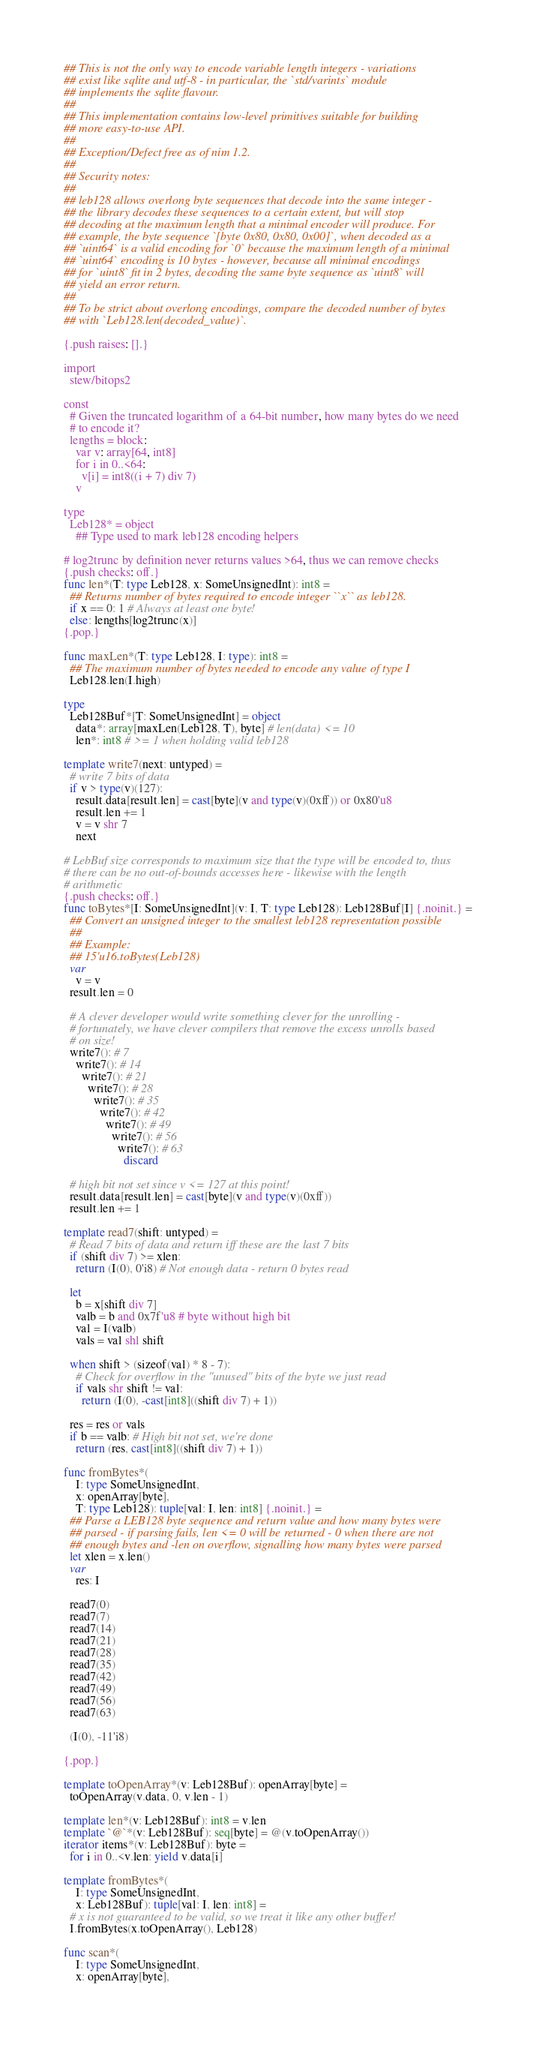Convert code to text. <code><loc_0><loc_0><loc_500><loc_500><_Nim_>## This is not the only way to encode variable length integers - variations
## exist like sqlite and utf-8 - in particular, the `std/varints` module
## implements the sqlite flavour.
##
## This implementation contains low-level primitives suitable for building
## more easy-to-use API.
##
## Exception/Defect free as of nim 1.2.
##
## Security notes:
##
## leb128 allows overlong byte sequences that decode into the same integer -
## the library decodes these sequences to a certain extent, but will stop
## decoding at the maximum length that a minimal encoder will produce. For
## example, the byte sequence `[byte 0x80, 0x80, 0x00]`, when decoded as a
## `uint64` is a valid encoding for `0` because the maximum length of a minimal
## `uint64` encoding is 10 bytes - however, because all minimal encodings
## for `uint8` fit in 2 bytes, decoding the same byte sequence as `uint8` will
## yield an error return.
##
## To be strict about overlong encodings, compare the decoded number of bytes
## with `Leb128.len(decoded_value)`.

{.push raises: [].}

import
  stew/bitops2

const
  # Given the truncated logarithm of a 64-bit number, how many bytes do we need
  # to encode it?
  lengths = block:
    var v: array[64, int8]
    for i in 0..<64:
      v[i] = int8((i + 7) div 7)
    v

type
  Leb128* = object
    ## Type used to mark leb128 encoding helpers

# log2trunc by definition never returns values >64, thus we can remove checks
{.push checks: off.}
func len*(T: type Leb128, x: SomeUnsignedInt): int8 =
  ## Returns number of bytes required to encode integer ``x`` as leb128.
  if x == 0: 1 # Always at least one byte!
  else: lengths[log2trunc(x)]
{.pop.}

func maxLen*(T: type Leb128, I: type): int8 =
  ## The maximum number of bytes needed to encode any value of type I
  Leb128.len(I.high)

type
  Leb128Buf*[T: SomeUnsignedInt] = object
    data*: array[maxLen(Leb128, T), byte] # len(data) <= 10
    len*: int8 # >= 1 when holding valid leb128

template write7(next: untyped) =
  # write 7 bits of data
  if v > type(v)(127):
    result.data[result.len] = cast[byte](v and type(v)(0xff)) or 0x80'u8
    result.len += 1
    v = v shr 7
    next

# LebBuf size corresponds to maximum size that the type will be encoded to, thus
# there can be no out-of-bounds accesses here - likewise with the length
# arithmetic
{.push checks: off.}
func toBytes*[I: SomeUnsignedInt](v: I, T: type Leb128): Leb128Buf[I] {.noinit.} =
  ## Convert an unsigned integer to the smallest leb128 representation possible
  ##
  ## Example:
  ## 15'u16.toBytes(Leb128)
  var
    v = v
  result.len = 0

  # A clever developer would write something clever for the unrolling -
  # fortunately, we have clever compilers that remove the excess unrolls based
  # on size!
  write7(): # 7
    write7(): # 14
      write7(): # 21
        write7(): # 28
          write7(): # 35
            write7(): # 42
              write7(): # 49
                write7(): # 56
                  write7(): # 63
                    discard

  # high bit not set since v <= 127 at this point!
  result.data[result.len] = cast[byte](v and type(v)(0xff))
  result.len += 1

template read7(shift: untyped) =
  # Read 7 bits of data and return iff these are the last 7 bits
  if (shift div 7) >= xlen:
    return (I(0), 0'i8) # Not enough data - return 0 bytes read

  let
    b = x[shift div 7]
    valb = b and 0x7f'u8 # byte without high bit
    val = I(valb)
    vals = val shl shift

  when shift > (sizeof(val) * 8 - 7):
    # Check for overflow in the "unused" bits of the byte we just read
    if vals shr shift != val:
      return (I(0), -cast[int8]((shift div 7) + 1))

  res = res or vals
  if b == valb: # High bit not set, we're done
    return (res, cast[int8]((shift div 7) + 1))

func fromBytes*(
    I: type SomeUnsignedInt,
    x: openArray[byte],
    T: type Leb128): tuple[val: I, len: int8] {.noinit.} =
  ## Parse a LEB128 byte sequence and return value and how many bytes were
  ## parsed - if parsing fails, len <= 0 will be returned - 0 when there are not
  ## enough bytes and -len on overflow, signalling how many bytes were parsed
  let xlen = x.len()
  var
    res: I

  read7(0)
  read7(7)
  read7(14)
  read7(21)
  read7(28)
  read7(35)
  read7(42)
  read7(49)
  read7(56)
  read7(63)

  (I(0), -11'i8)

{.pop.}

template toOpenArray*(v: Leb128Buf): openArray[byte] =
  toOpenArray(v.data, 0, v.len - 1)

template len*(v: Leb128Buf): int8 = v.len
template `@`*(v: Leb128Buf): seq[byte] = @(v.toOpenArray())
iterator items*(v: Leb128Buf): byte =
  for i in 0..<v.len: yield v.data[i]

template fromBytes*(
    I: type SomeUnsignedInt,
    x: Leb128Buf): tuple[val: I, len: int8] =
  # x is not guaranteed to be valid, so we treat it like any other buffer!
  I.fromBytes(x.toOpenArray(), Leb128)

func scan*(
    I: type SomeUnsignedInt,
    x: openArray[byte],</code> 